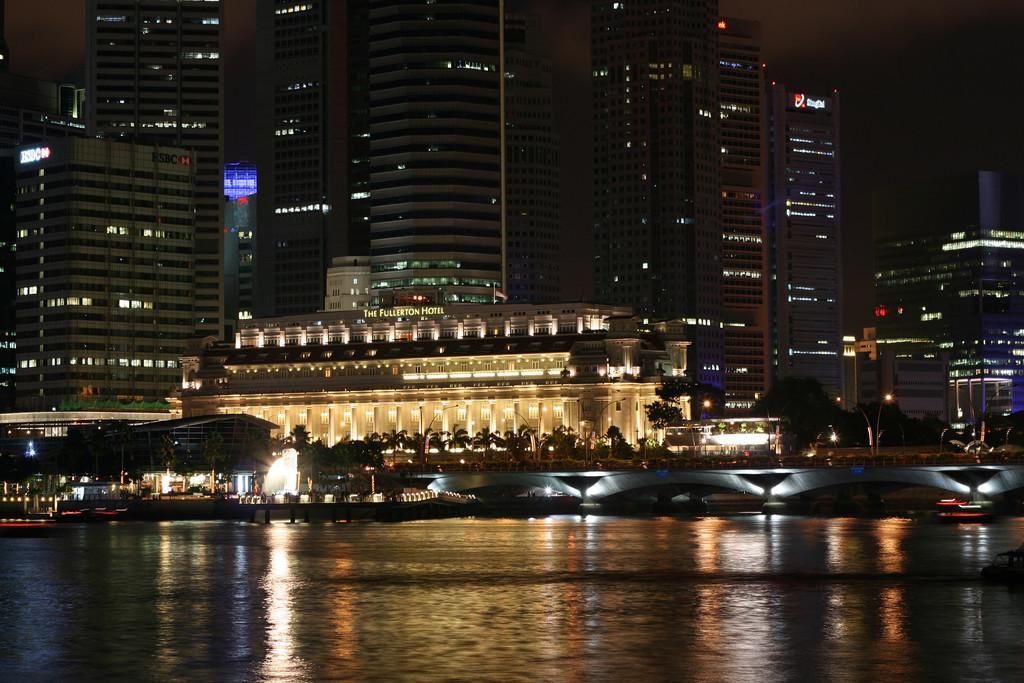What type of structures can be seen in the image? There are buildings in the image. What natural elements are present in the image? There are trees in the image. What man-made objects can be seen in the image? There are poles and lights visible in the image. What type of surface is visible in the image? There is water and ground visible in the image. What additional objects are present in the image? There are boards with text in the image. How would you describe the sky in the image? The sky is dark in the image. What type of birthday celebration is taking place in the image? There is no indication of a birthday celebration in the image. How many feet are visible in the image? There are no feet visible in the image. 